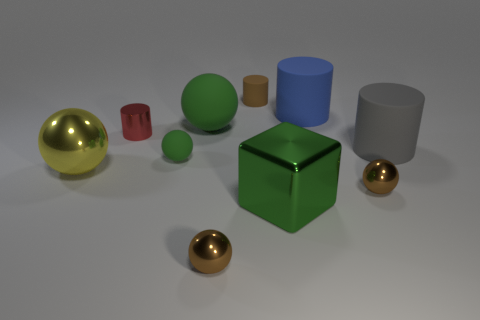Subtract all gray matte cylinders. How many cylinders are left? 3 Subtract all brown spheres. How many spheres are left? 3 Subtract 5 balls. How many balls are left? 0 Subtract all cylinders. How many objects are left? 6 Subtract all blue blocks. How many green spheres are left? 2 Subtract all large blue matte cylinders. Subtract all tiny red things. How many objects are left? 8 Add 9 metal cylinders. How many metal cylinders are left? 10 Add 5 yellow things. How many yellow things exist? 6 Subtract 0 purple balls. How many objects are left? 10 Subtract all gray cylinders. Subtract all cyan balls. How many cylinders are left? 3 